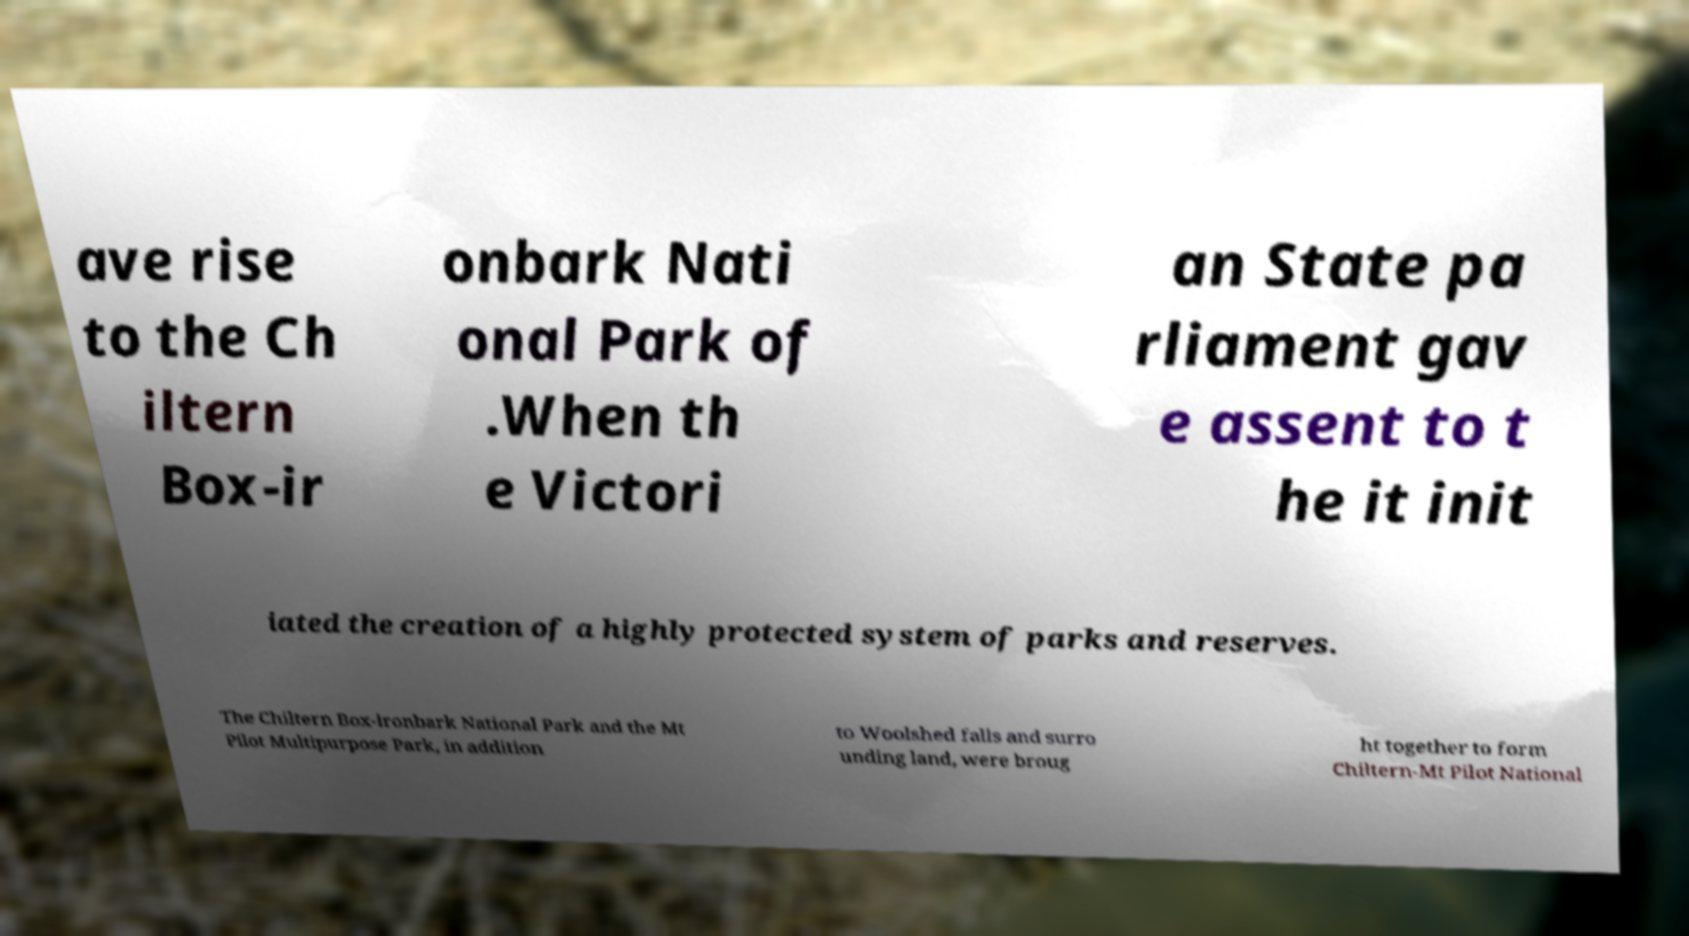I need the written content from this picture converted into text. Can you do that? ave rise to the Ch iltern Box-ir onbark Nati onal Park of .When th e Victori an State pa rliament gav e assent to t he it init iated the creation of a highly protected system of parks and reserves. The Chiltern Box-ironbark National Park and the Mt Pilot Multipurpose Park, in addition to Woolshed falls and surro unding land, were broug ht together to form Chiltern-Mt Pilot National 